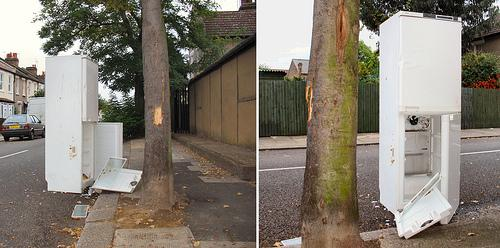List three other objects observed in the image besides the broken white refrigerator. Very thick tree trunk, beautiful bushes and roses, tall green fencing covering a house. For a visual entailment task, provide a statement about the image that must be true based on the given information. A broken refrigerator is discarded on the road, surrounded by elements like tree trunks, a green fence, and a car in the background. In the context of a VQA task, answer the question: What type of the vehicle is visible and where is it located? A gray car is parked on the street in the background. Identify the type of green structure that is mentioned multiple times in the image and its location relative to a specific house. A tall green fence in the background covering a house. Choose a caption that best describes the position of the refrigerator and provide an alternative description. Original: Old refrigerator sitting next to the curb. Alternative: Discarded white fridge near the sidewalk. What is the most noticeable object in the image that seems to be broken? An extremely broken white refrigerator in the street with its door broken off. Describe the natural element observed in the image that is contrasted with a man-made object. A large, thick tree trunk is contrasted with the broken white refrigerator on the street. For a product advertisement task, describe the condition of the refrigerator and propose a solution. Tired of your old, broken refrigerator lying in the street? Upgrade to a new, energy-efficient model today! Abstractly describe the scene captured in the image. A juxtaposition of nature and discarded home appliances, with a broken refrigerator amidst trees, a fence, and a distant car. 